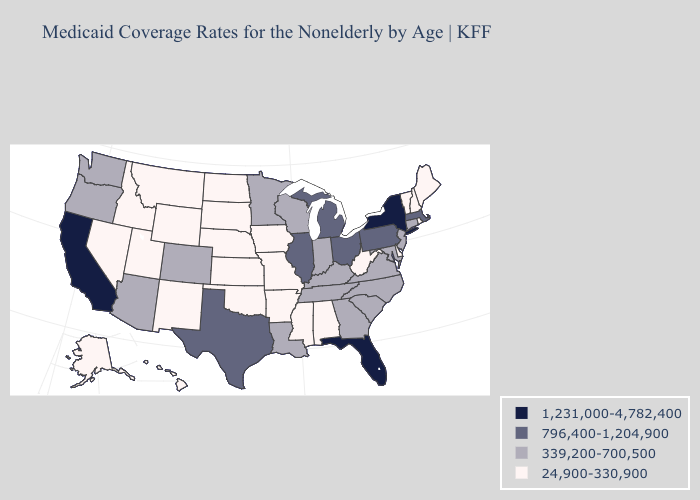Does Florida have the highest value in the USA?
Answer briefly. Yes. Does New Jersey have the highest value in the Northeast?
Short answer required. No. Name the states that have a value in the range 339,200-700,500?
Give a very brief answer. Arizona, Colorado, Connecticut, Georgia, Indiana, Kentucky, Louisiana, Maryland, Minnesota, New Jersey, North Carolina, Oregon, South Carolina, Tennessee, Virginia, Washington, Wisconsin. Name the states that have a value in the range 339,200-700,500?
Be succinct. Arizona, Colorado, Connecticut, Georgia, Indiana, Kentucky, Louisiana, Maryland, Minnesota, New Jersey, North Carolina, Oregon, South Carolina, Tennessee, Virginia, Washington, Wisconsin. What is the value of Washington?
Be succinct. 339,200-700,500. Name the states that have a value in the range 1,231,000-4,782,400?
Short answer required. California, Florida, New York. Which states hav the highest value in the South?
Answer briefly. Florida. What is the lowest value in states that border New Mexico?
Be succinct. 24,900-330,900. Name the states that have a value in the range 1,231,000-4,782,400?
Give a very brief answer. California, Florida, New York. What is the lowest value in the West?
Short answer required. 24,900-330,900. Which states have the lowest value in the USA?
Short answer required. Alabama, Alaska, Arkansas, Delaware, Hawaii, Idaho, Iowa, Kansas, Maine, Mississippi, Missouri, Montana, Nebraska, Nevada, New Hampshire, New Mexico, North Dakota, Oklahoma, Rhode Island, South Dakota, Utah, Vermont, West Virginia, Wyoming. Name the states that have a value in the range 24,900-330,900?
Answer briefly. Alabama, Alaska, Arkansas, Delaware, Hawaii, Idaho, Iowa, Kansas, Maine, Mississippi, Missouri, Montana, Nebraska, Nevada, New Hampshire, New Mexico, North Dakota, Oklahoma, Rhode Island, South Dakota, Utah, Vermont, West Virginia, Wyoming. Does Florida have the highest value in the South?
Write a very short answer. Yes. What is the value of North Dakota?
Quick response, please. 24,900-330,900. 